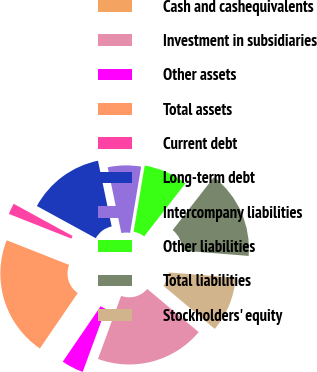Convert chart to OTSL. <chart><loc_0><loc_0><loc_500><loc_500><pie_chart><fcel>Cash and cashequivalents<fcel>Investment in subsidiaries<fcel>Other assets<fcel>Total assets<fcel>Current debt<fcel>Long-term debt<fcel>Intercompany liabilities<fcel>Other liabilities<fcel>Total liabilities<fcel>Stockholders' equity<nl><fcel>0.0%<fcel>19.48%<fcel>3.94%<fcel>21.45%<fcel>1.97%<fcel>13.77%<fcel>5.91%<fcel>7.88%<fcel>15.74%<fcel>9.85%<nl></chart> 